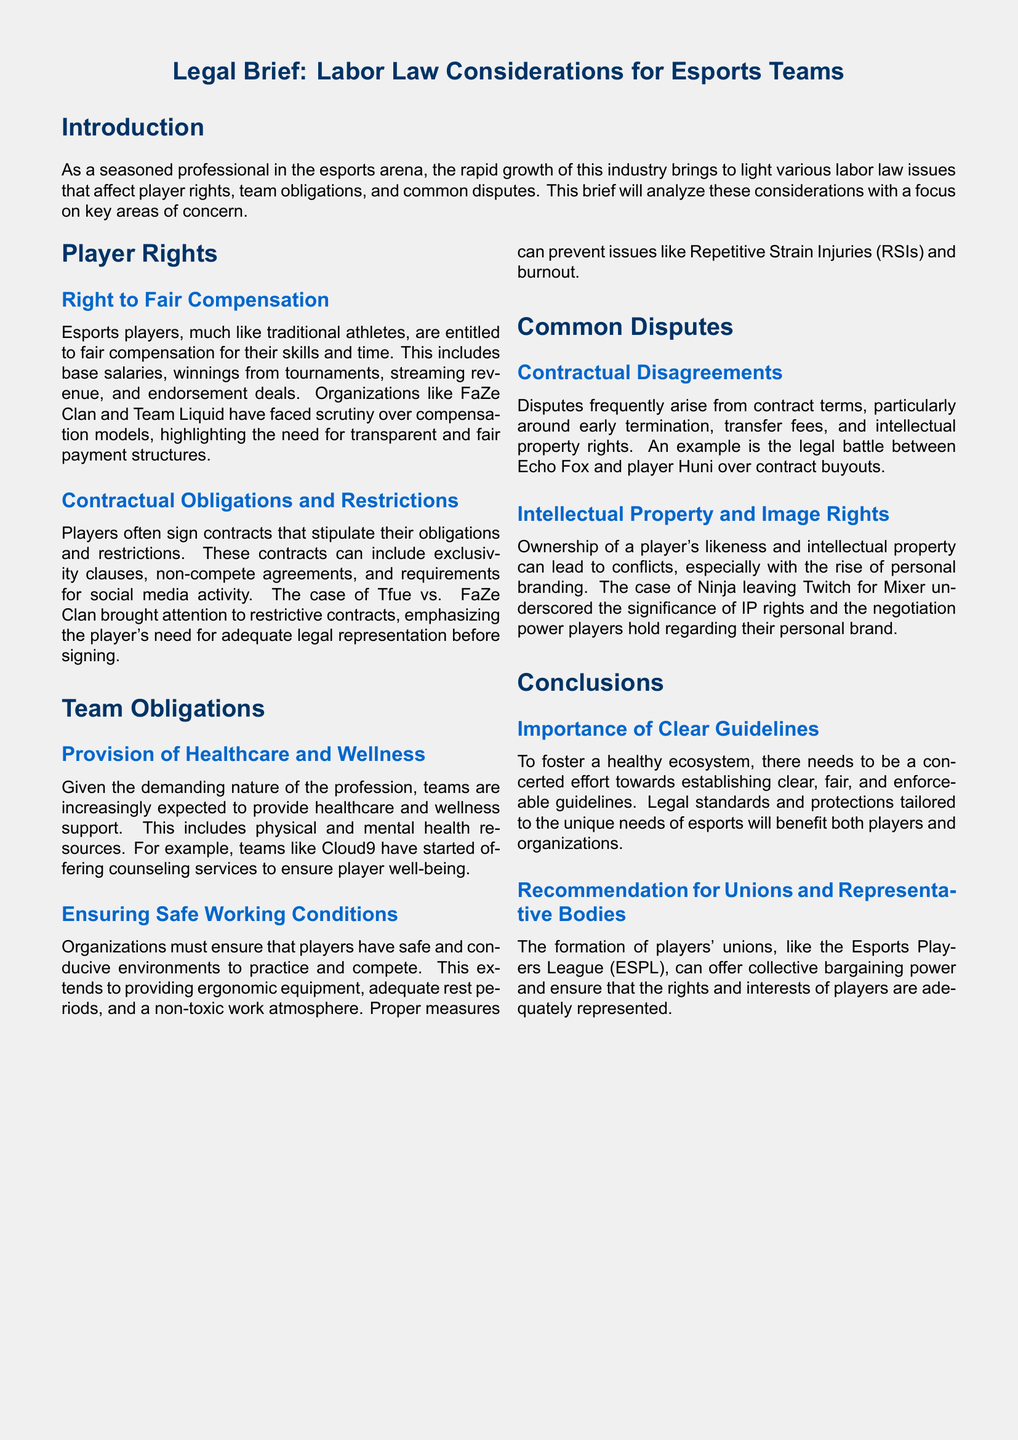What is the focus of the legal brief? The focus of the legal brief is on labor law considerations specific to esports teams, including player rights and team obligations.
Answer: Labor law considerations specific to esports teams What are players entitled to according to the document? Players are entitled to fair compensation, which includes base salaries, winnings, streaming revenue, and endorsement deals.
Answer: Fair compensation What is one of the obligations of esports teams mentioned? Esports teams have the obligation to provide healthcare and wellness support to their players.
Answer: Provide healthcare and wellness support What common dispute is mentioned related to contracts? A common dispute mentioned is contractual disagreements, particularly around early termination and transfer fees.
Answer: Contractual disagreements Which esports team is cited for offering counseling services? The esports team cited for offering counseling services is Cloud9.
Answer: Cloud9 What legal case is highlighted regarding restrictive contracts? The legal case highlighted regarding restrictive contracts is Tfue vs. FaZe Clan.
Answer: Tfue vs. FaZe Clan What does the document recommend for player representation? The document recommends the formation of players' unions, like the Esports Players League (ESPL).
Answer: Players' unions, like the Esports Players League (ESPL) What issue can arise from ownership of a player's likeness? Conflicts can arise from ownership of a player's likeness and intellectual property, particularly with personal branding.
Answer: Conflicts over likeness and intellectual property What is emphasized as important for esports ecosystem health? The document emphasizes the importance of clear, fair, and enforceable guidelines for the esports ecosystem.
Answer: Clear, fair, and enforceable guidelines 